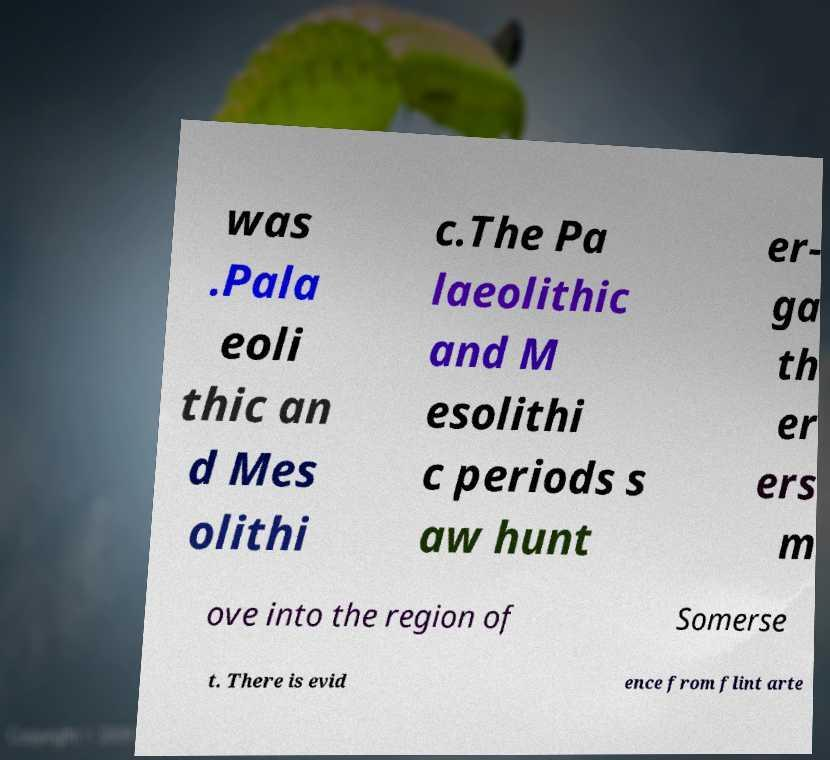Could you extract and type out the text from this image? was .Pala eoli thic an d Mes olithi c.The Pa laeolithic and M esolithi c periods s aw hunt er- ga th er ers m ove into the region of Somerse t. There is evid ence from flint arte 